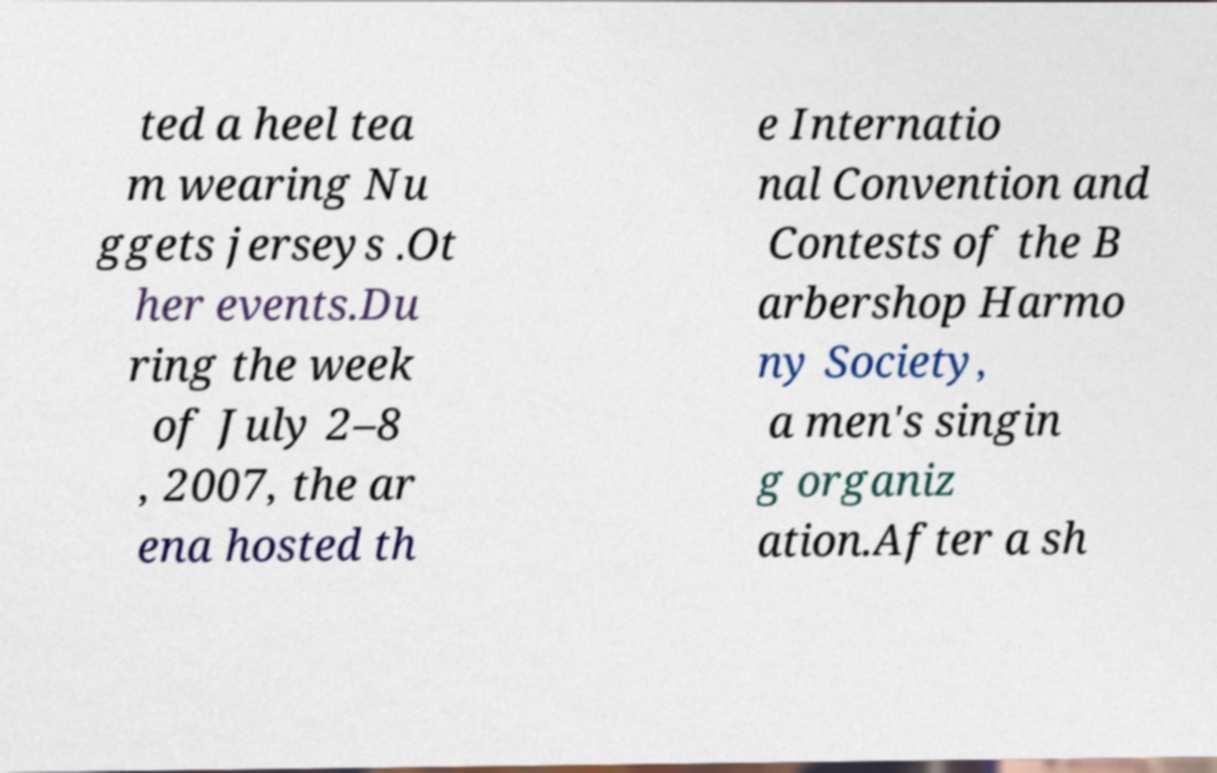Could you extract and type out the text from this image? ted a heel tea m wearing Nu ggets jerseys .Ot her events.Du ring the week of July 2–8 , 2007, the ar ena hosted th e Internatio nal Convention and Contests of the B arbershop Harmo ny Society, a men's singin g organiz ation.After a sh 